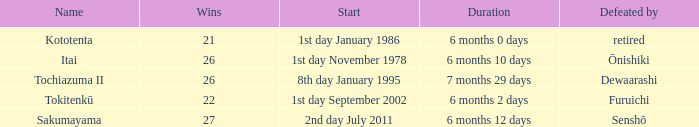Which duration was defeated by retired? 6 months 0 days. 